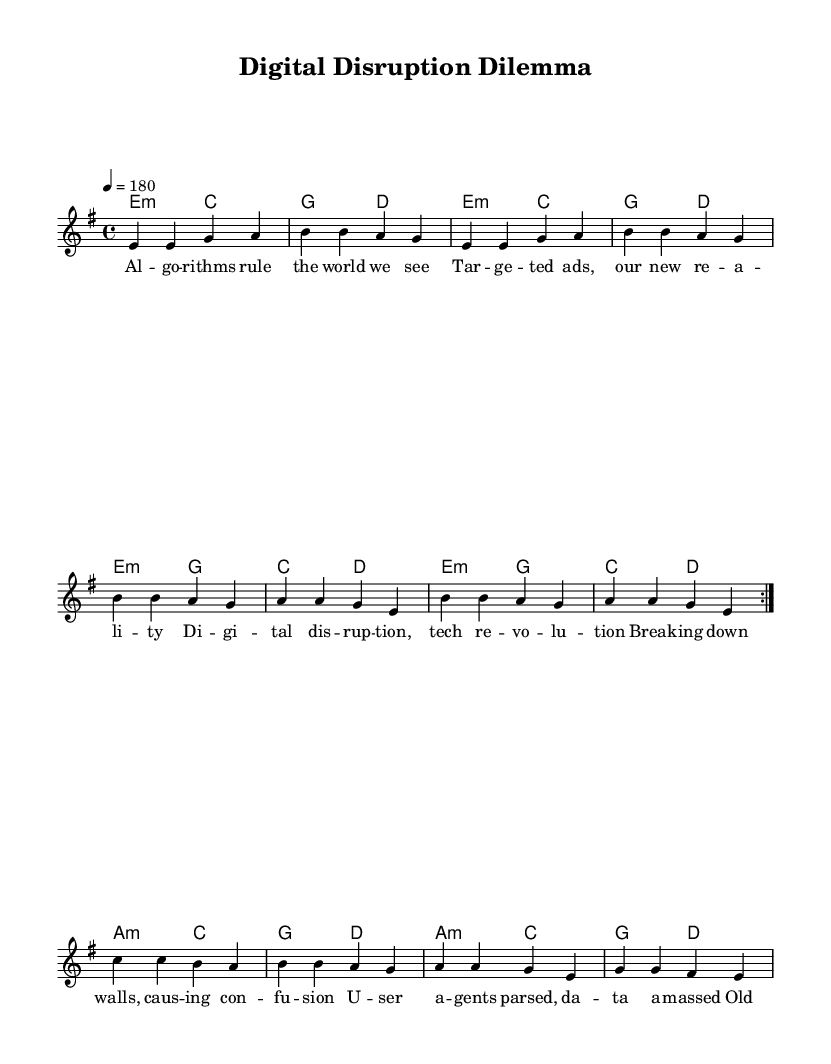What is the key signature of this music? The key signature is E minor, which is indicated by one sharp (F#) in the music. This can be identified from the global section where it states \key e \minor.
Answer: E minor What is the time signature of this music? The time signature is 4/4, which means there are four beats in each measure and a quarter note gets one beat. This is indicated in the global section with \time 4/4.
Answer: 4/4 What is the tempo marking for this piece? The tempo marking is 180 beats per minute, as indicated by \tempo 4 = 180 in the global section. This directs the performer to play the music at a fast pace.
Answer: 180 How many measures are repeated in the melody? The melody indicates a repeat of two measures, shown by \repeat volta 2 in the melody section. This means the first two measures will be played twice before moving forward.
Answer: 2 What is the style of the lyrics presented in the sheet music? The lyrics are intended to reflect themes of digital disruption and technology, which aligns with the punk aesthetic of critiquing societal norms. The use of sharp, direct language suggests an energetic and rebellious tone typical of punk music.
Answer: Punk What chord is used at the beginning of the harmonic progression? The first chord is E minor, which is evident from the harmonies section where the chordmode starts with e2:m. This indicates that the music begins with the root chord of the key signature, reinforcing its tonal center.
Answer: E minor How many lines of lyrics are presented in the bridge section? The bridge section contains two lines of lyrics, clearly delineated by the structure of the lyric mode in the code, which separates them into distinct phrases for clarity in performance.
Answer: 2 